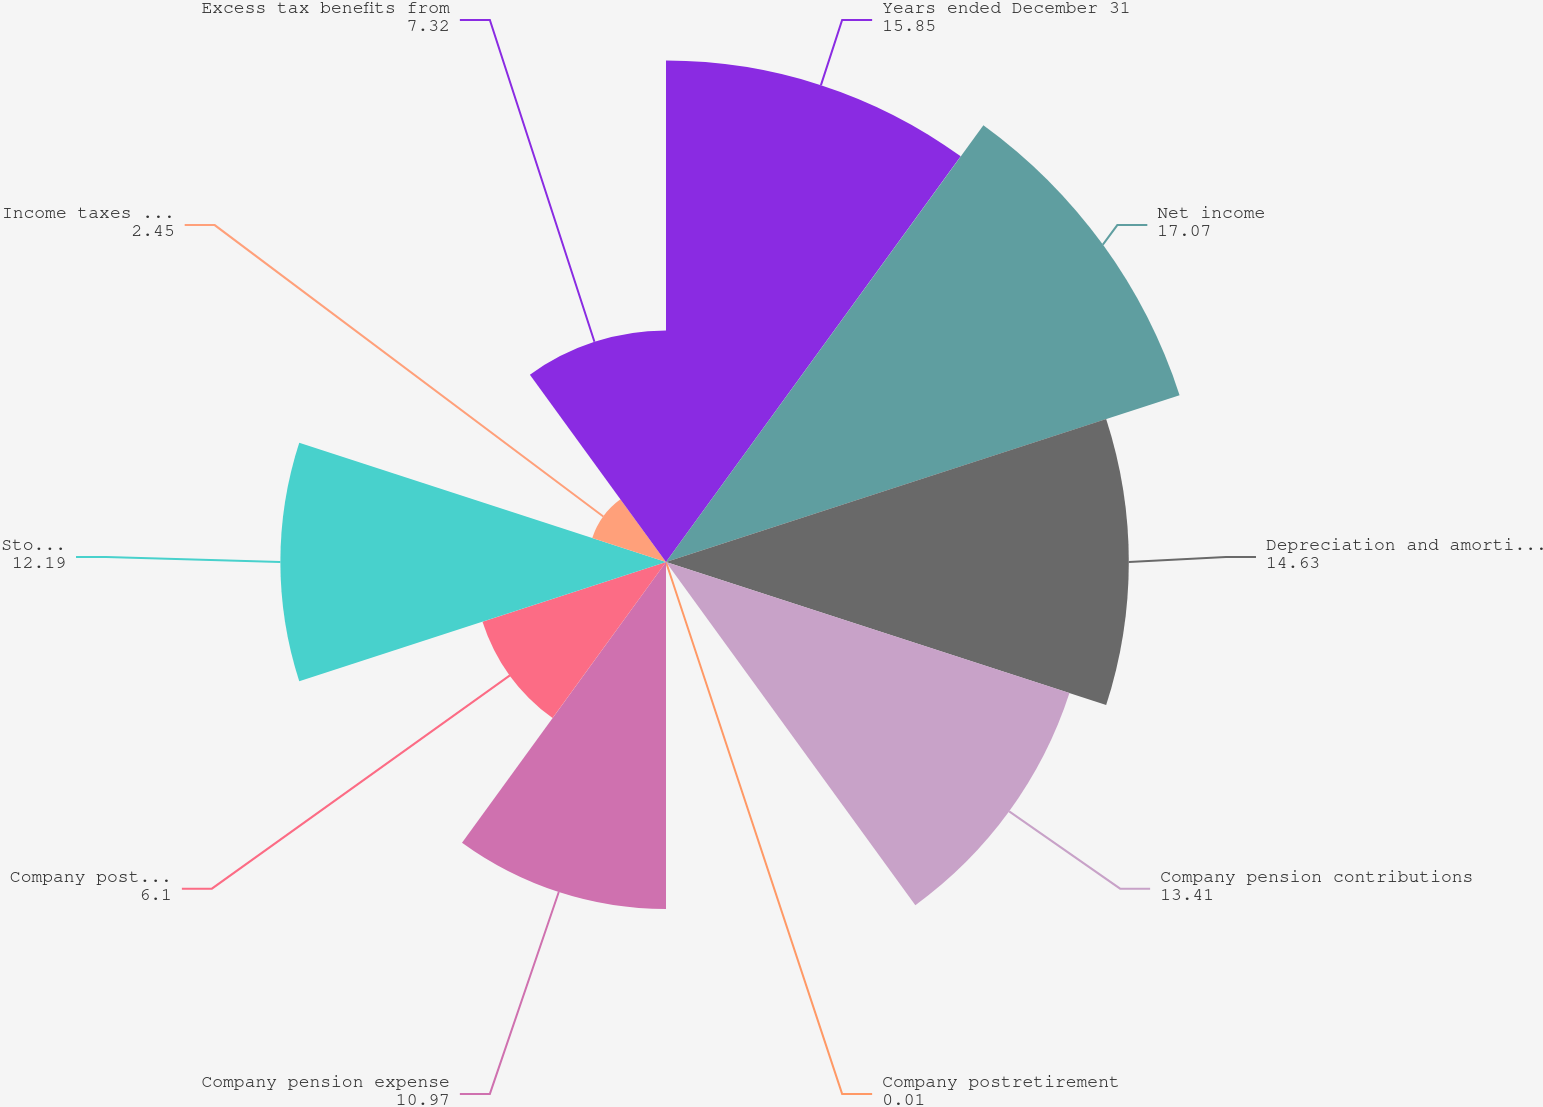Convert chart to OTSL. <chart><loc_0><loc_0><loc_500><loc_500><pie_chart><fcel>Years ended December 31<fcel>Net income<fcel>Depreciation and amortization<fcel>Company pension contributions<fcel>Company postretirement<fcel>Company pension expense<fcel>Company postretirement expense<fcel>Stock-based compensation<fcel>Income taxes (deferred and<fcel>Excess tax benefits from<nl><fcel>15.85%<fcel>17.07%<fcel>14.63%<fcel>13.41%<fcel>0.01%<fcel>10.97%<fcel>6.1%<fcel>12.19%<fcel>2.45%<fcel>7.32%<nl></chart> 